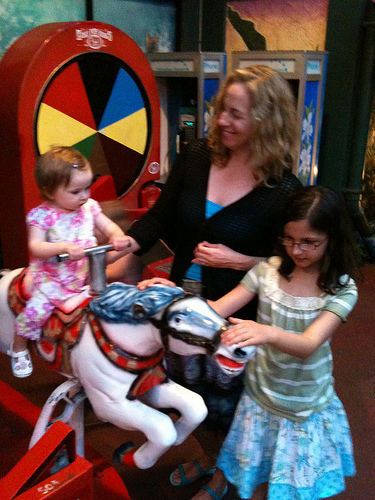<image>
Is the girl to the right of the wheel? Yes. From this viewpoint, the girl is positioned to the right side relative to the wheel. 